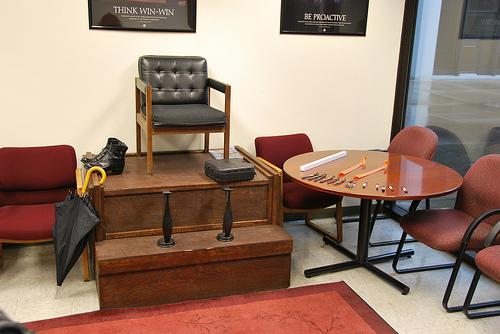Identify the color and texture of the main chair in the image. The main chair is black and made of wood and leather. What is the largest item in the image according to the given dimensions? The largest item in the image is the round tabletop with Width:202 and Height:202. Count the number of objects related to seating in the image. There are four chairs and one shoeshine stand for seating. Tell me what the boots in the image are made of and their color. The boots in the image are made of black leather. Provide a brief description of the items on the ground. There are red carpets on the ground, a black umbrella, and a mat. What color is the wall in the image and is there anything notable about it? The wall is white in color and appears to be plain. What is the shape of the tabletop and what color is the umbrella? The tabletop is round, and the umbrella is black. Describe the interaction between the chairs and the other objects in the image. There is no direct interaction between chairs and other objects, but the chairs are placed near other objects like a shoeshine stand, umbrella, and carpets. Identify the sentiment or mood of the image based on the given information. The image has a neutral sentiment, as it consists primarily of everyday objects and furniture with no emotional cues. 